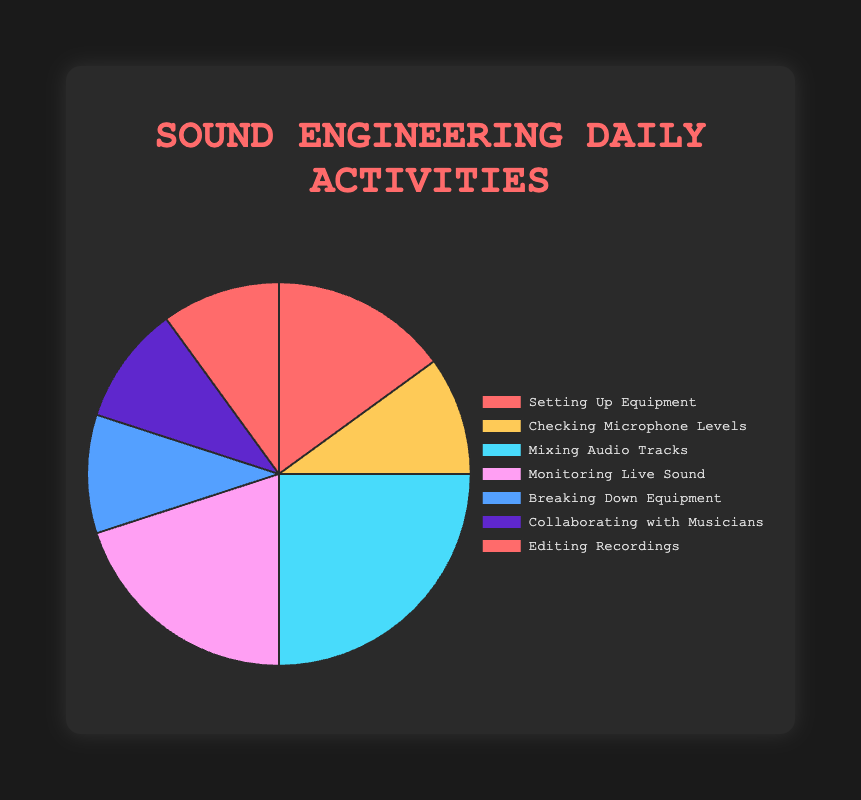What's the most time-consuming activity in daily sound engineering tasks? The largest portion of the pie chart represents the most time-consuming activity. "Mixing Audio Tracks" occupies the largest share, which is 25%.
Answer: Mixing Audio Tracks Which activities take up the same amount of time daily? The pie chart shows multiple activities occupying the same percentage of the chart. "Checking Microphone Levels", "Breaking Down Equipment", "Collaborating with Musicians", and "Editing Recordings" all occupy 10% each.
Answer: Checking Microphone Levels, Breaking Down Equipment, Collaborating with Musicians, Editing Recordings How much more time is spent on 'Monitoring Live Sound' compared to 'Checking Microphone Levels'? 'Monitoring Live Sound' takes up 20% while 'Checking Microphone Levels' takes up 10%. The difference is 20% - 10% = 10%.
Answer: 10% What is the total percentage of time spent on setting up and breaking down equipment? Adding the percentages for 'Setting Up Equipment' (15%) and 'Breaking Down Equipment' (10%), we get 15% + 10% = 25%.
Answer: 25% Which activity has a light blue color in the pie chart? By checking the colors assigned to different activities in the pie chart, 'Mixing Audio Tracks' is shown in light blue.
Answer: Mixing Audio Tracks Arrange the activities by the amount of time spent on them, from most to least. Refer to the chart for the percentages: 'Mixing Audio Tracks' (25%) > 'Monitoring Live Sound' (20%) > 'Setting Up Equipment' (15%) > 'Checking Microphone Levels', 'Breaking Down Equipment', 'Collaborating with Musicians', 'Editing Recordings' (each 10%).
Answer: Mixing Audio Tracks, Monitoring Live Sound, Setting Up Equipment, Checking Microphone Levels, Breaking Down Equipment, Collaborating with Musicians, Editing Recordings What's the combined percentage of time spent collaborating with musicians and editing recordings? Adding the percentages for 'Collaborating with Musicians' (10%) and 'Editing Recordings' (10%), we get 10% + 10% = 20%.
Answer: 20% Which activity takes just as much time as breaking down equipment? Both 'Breaking Down Equipment' and 'Editing Recordings' occupy 10% each in the pie chart.
Answer: Editing Recordings What's the total percentage of time spent on activities related to equipment (i.e., 'Setting Up Equipment' and 'Breaking Down Equipment')? Adding the percentages for 'Setting Up Equipment' (15%) and 'Breaking Down Equipment' (10%), we get 15% + 10% = 25%.
Answer: 25% 